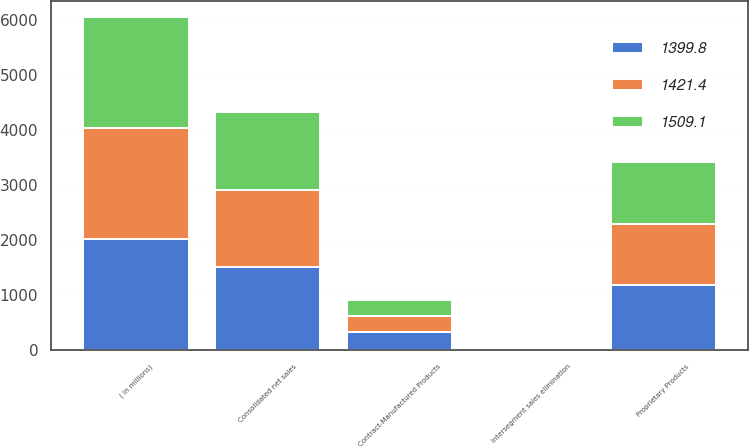Convert chart to OTSL. <chart><loc_0><loc_0><loc_500><loc_500><stacked_bar_chart><ecel><fcel>( in millions)<fcel>Proprietary Products<fcel>Contract-Manufactured Products<fcel>Intersegment sales elimination<fcel>Consolidated net sales<nl><fcel>1399.8<fcel>2016<fcel>1189.9<fcel>320.2<fcel>1<fcel>1509.1<nl><fcel>1421.4<fcel>2015<fcel>1098.3<fcel>302.4<fcel>0.9<fcel>1399.8<nl><fcel>1509.1<fcel>2014<fcel>1126.3<fcel>295.7<fcel>0.6<fcel>1421.4<nl></chart> 